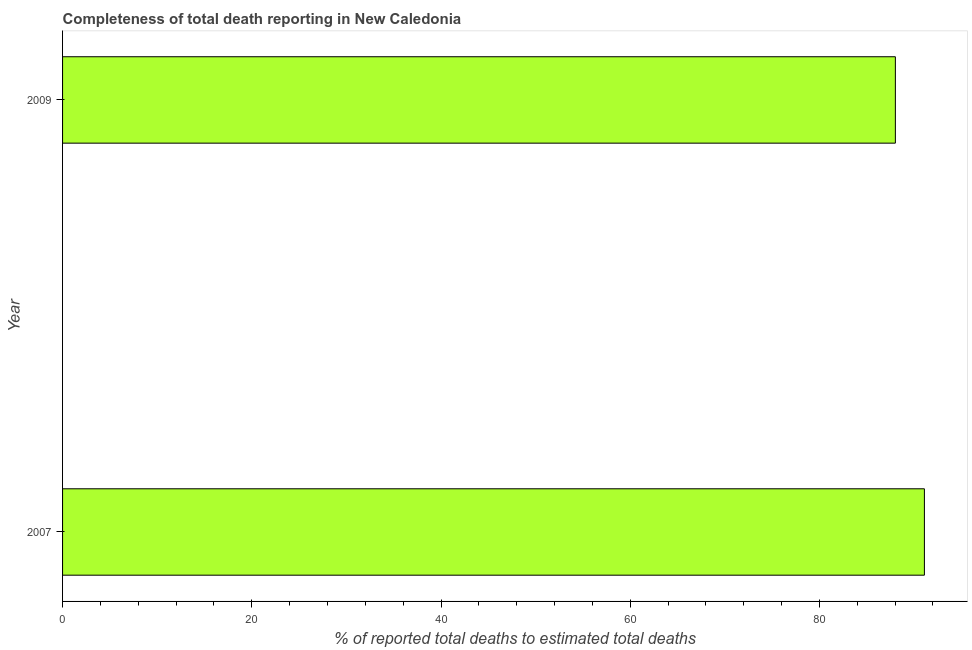Does the graph contain any zero values?
Provide a short and direct response. No. What is the title of the graph?
Make the answer very short. Completeness of total death reporting in New Caledonia. What is the label or title of the X-axis?
Your response must be concise. % of reported total deaths to estimated total deaths. What is the completeness of total death reports in 2007?
Give a very brief answer. 91.09. Across all years, what is the maximum completeness of total death reports?
Offer a terse response. 91.09. Across all years, what is the minimum completeness of total death reports?
Make the answer very short. 88.03. In which year was the completeness of total death reports minimum?
Offer a very short reply. 2009. What is the sum of the completeness of total death reports?
Make the answer very short. 179.12. What is the difference between the completeness of total death reports in 2007 and 2009?
Provide a succinct answer. 3.07. What is the average completeness of total death reports per year?
Offer a terse response. 89.56. What is the median completeness of total death reports?
Your answer should be compact. 89.56. Do a majority of the years between 2009 and 2007 (inclusive) have completeness of total death reports greater than 56 %?
Your answer should be compact. No. What is the ratio of the completeness of total death reports in 2007 to that in 2009?
Your answer should be very brief. 1.03. Is the completeness of total death reports in 2007 less than that in 2009?
Provide a short and direct response. No. In how many years, is the completeness of total death reports greater than the average completeness of total death reports taken over all years?
Offer a terse response. 1. How many bars are there?
Keep it short and to the point. 2. Are all the bars in the graph horizontal?
Make the answer very short. Yes. What is the difference between two consecutive major ticks on the X-axis?
Your answer should be compact. 20. What is the % of reported total deaths to estimated total deaths in 2007?
Your response must be concise. 91.09. What is the % of reported total deaths to estimated total deaths of 2009?
Provide a succinct answer. 88.03. What is the difference between the % of reported total deaths to estimated total deaths in 2007 and 2009?
Give a very brief answer. 3.07. What is the ratio of the % of reported total deaths to estimated total deaths in 2007 to that in 2009?
Make the answer very short. 1.03. 